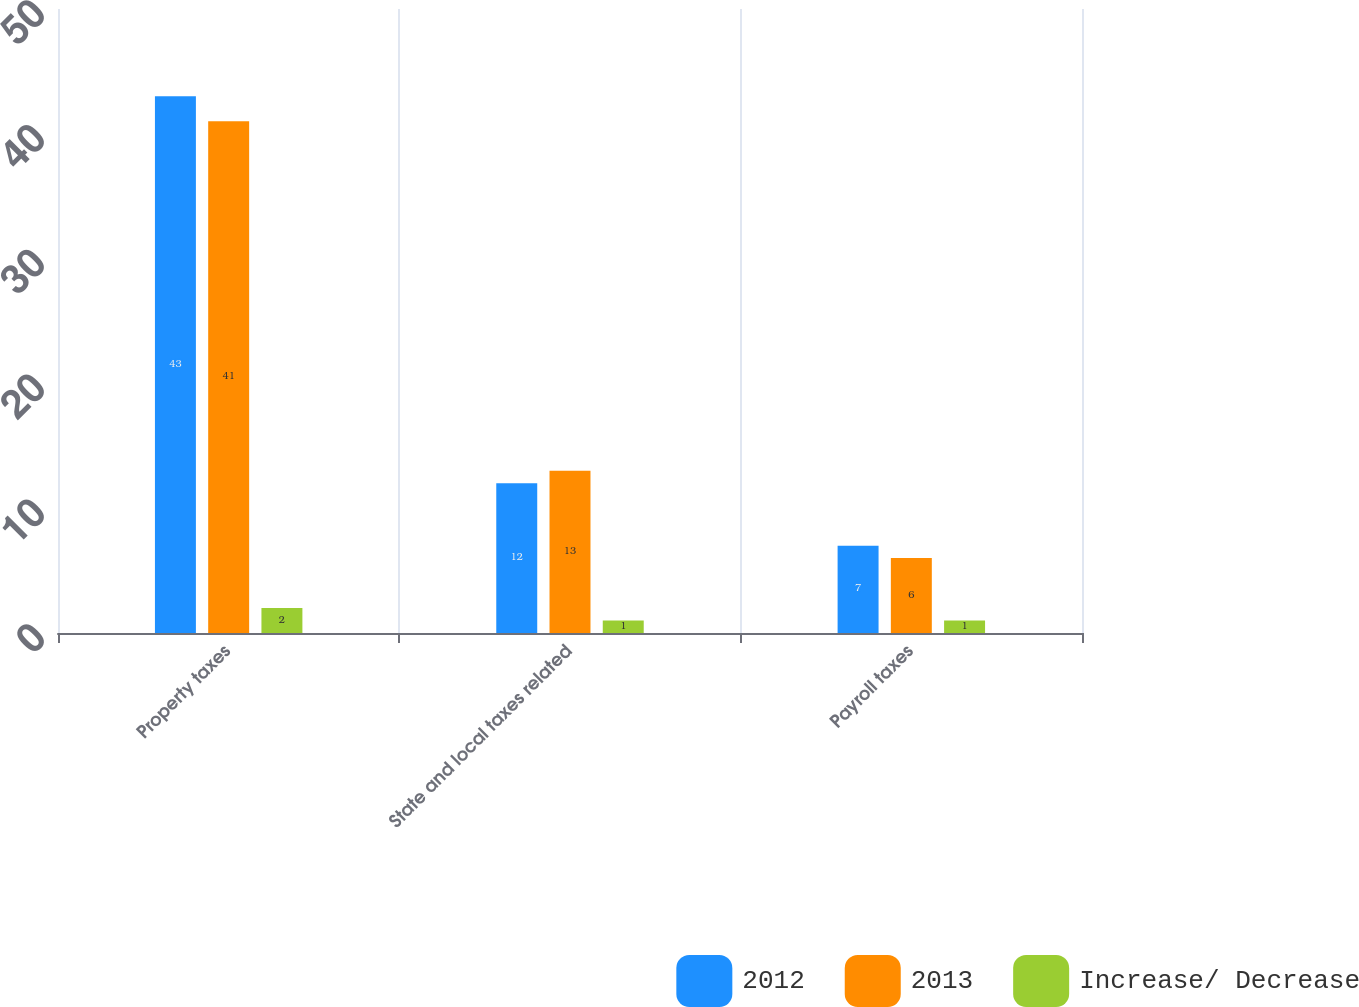Convert chart. <chart><loc_0><loc_0><loc_500><loc_500><stacked_bar_chart><ecel><fcel>Property taxes<fcel>State and local taxes related<fcel>Payroll taxes<nl><fcel>2012<fcel>43<fcel>12<fcel>7<nl><fcel>2013<fcel>41<fcel>13<fcel>6<nl><fcel>Increase/ Decrease<fcel>2<fcel>1<fcel>1<nl></chart> 